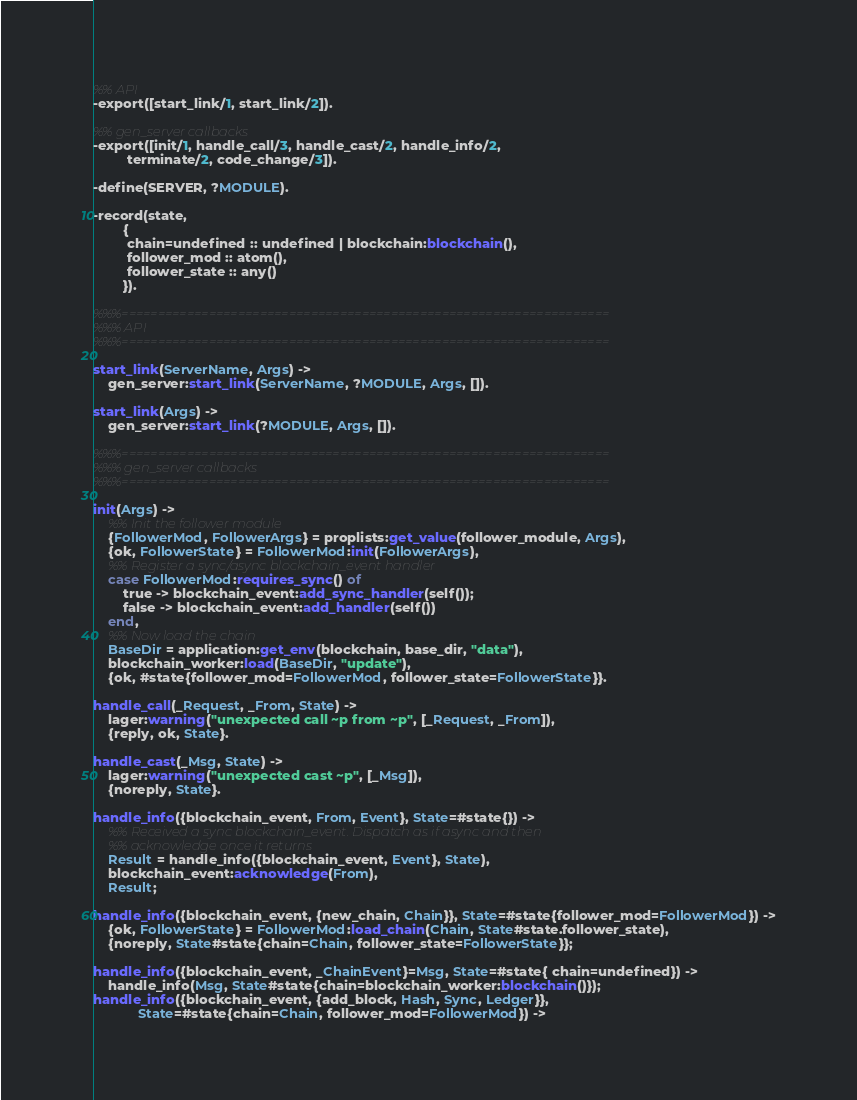<code> <loc_0><loc_0><loc_500><loc_500><_Erlang_>%% API
-export([start_link/1, start_link/2]).

%% gen_server callbacks
-export([init/1, handle_call/3, handle_cast/2, handle_info/2,
         terminate/2, code_change/3]).

-define(SERVER, ?MODULE).

-record(state,
        {
         chain=undefined :: undefined | blockchain:blockchain(),
         follower_mod :: atom(),
         follower_state :: any()
        }).

%%%===================================================================
%%% API
%%%===================================================================

start_link(ServerName, Args) ->
    gen_server:start_link(ServerName, ?MODULE, Args, []).

start_link(Args) ->
    gen_server:start_link(?MODULE, Args, []).

%%%===================================================================
%%% gen_server callbacks
%%%===================================================================

init(Args) ->
    %% Init the follower module
    {FollowerMod, FollowerArgs} = proplists:get_value(follower_module, Args),
    {ok, FollowerState} = FollowerMod:init(FollowerArgs),
    %% Register a sync/async blockchain_event handler
    case FollowerMod:requires_sync() of
        true -> blockchain_event:add_sync_handler(self());
        false -> blockchain_event:add_handler(self())
    end,
    %% Now load the chain
    BaseDir = application:get_env(blockchain, base_dir, "data"),
    blockchain_worker:load(BaseDir, "update"),
    {ok, #state{follower_mod=FollowerMod, follower_state=FollowerState}}.

handle_call(_Request, _From, State) ->
    lager:warning("unexpected call ~p from ~p", [_Request, _From]),
    {reply, ok, State}.

handle_cast(_Msg, State) ->
    lager:warning("unexpected cast ~p", [_Msg]),
    {noreply, State}.

handle_info({blockchain_event, From, Event}, State=#state{}) ->
    %% Received a sync blockchain_event. Dispatch as if async and then
    %% acknowledge once it returns
    Result = handle_info({blockchain_event, Event}, State),
    blockchain_event:acknowledge(From),
    Result;

handle_info({blockchain_event, {new_chain, Chain}}, State=#state{follower_mod=FollowerMod}) ->
    {ok, FollowerState} = FollowerMod:load_chain(Chain, State#state.follower_state),
    {noreply, State#state{chain=Chain, follower_state=FollowerState}};

handle_info({blockchain_event, _ChainEvent}=Msg, State=#state{ chain=undefined}) ->
    handle_info(Msg, State#state{chain=blockchain_worker:blockchain()});
handle_info({blockchain_event, {add_block, Hash, Sync, Ledger}},
            State=#state{chain=Chain, follower_mod=FollowerMod}) -></code> 